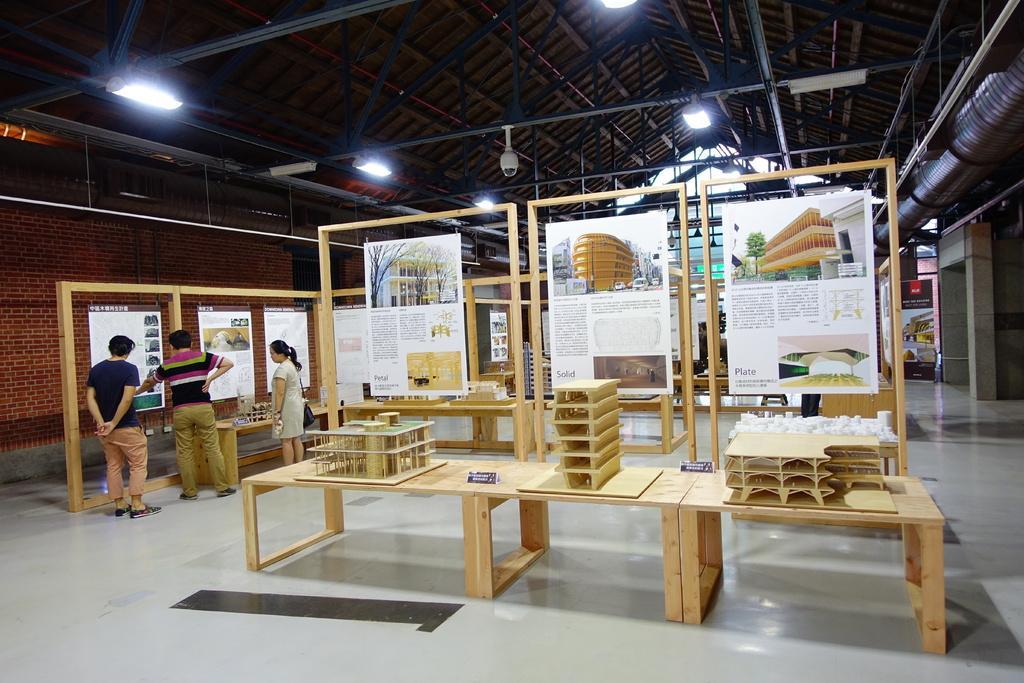How would you summarize this image in a sentence or two? In the middle we can see building plans placed on a table and above them we can see posters of each plans on the left side we can see three people Standing and observing to the posters present and on the top we can see lights 